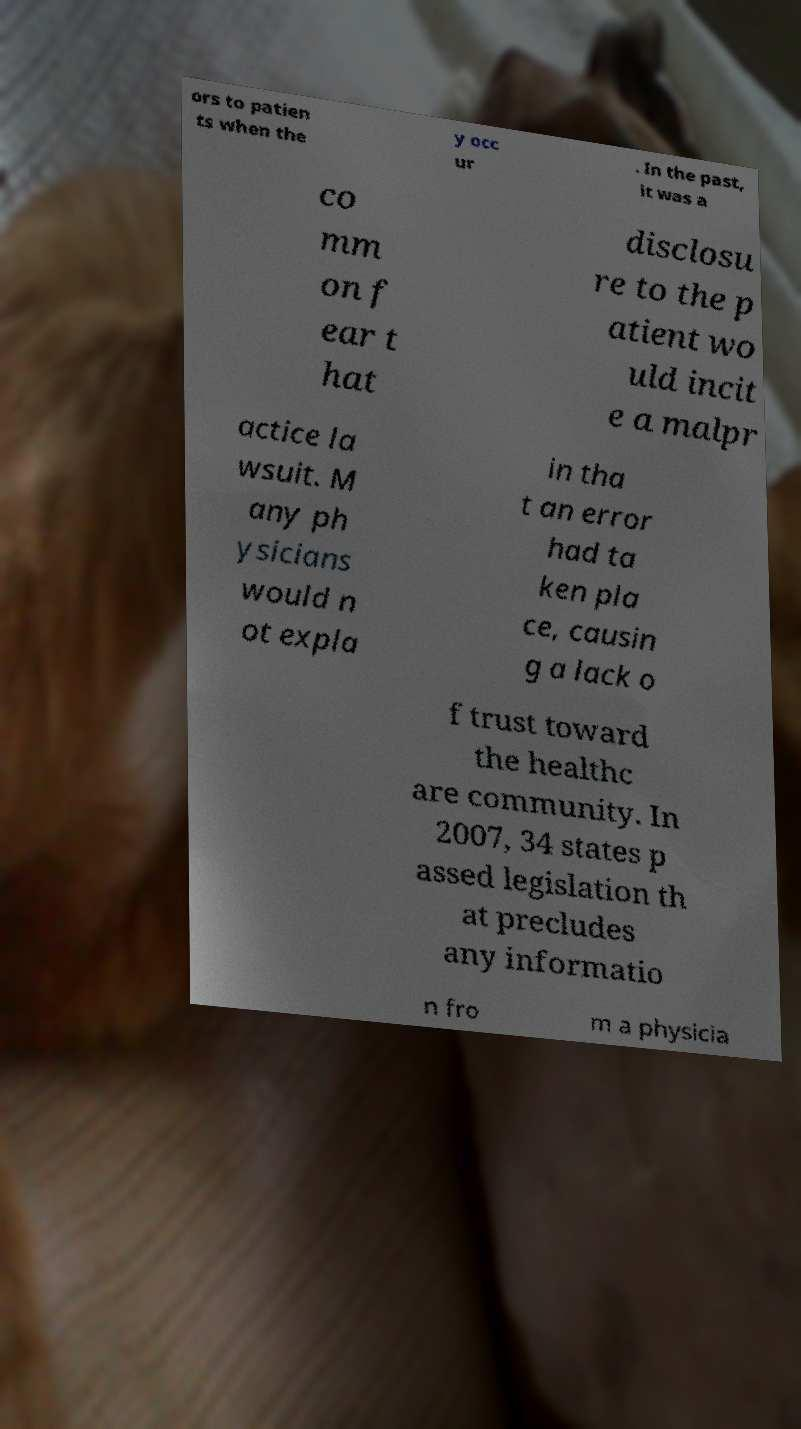For documentation purposes, I need the text within this image transcribed. Could you provide that? ors to patien ts when the y occ ur . In the past, it was a co mm on f ear t hat disclosu re to the p atient wo uld incit e a malpr actice la wsuit. M any ph ysicians would n ot expla in tha t an error had ta ken pla ce, causin g a lack o f trust toward the healthc are community. In 2007, 34 states p assed legislation th at precludes any informatio n fro m a physicia 